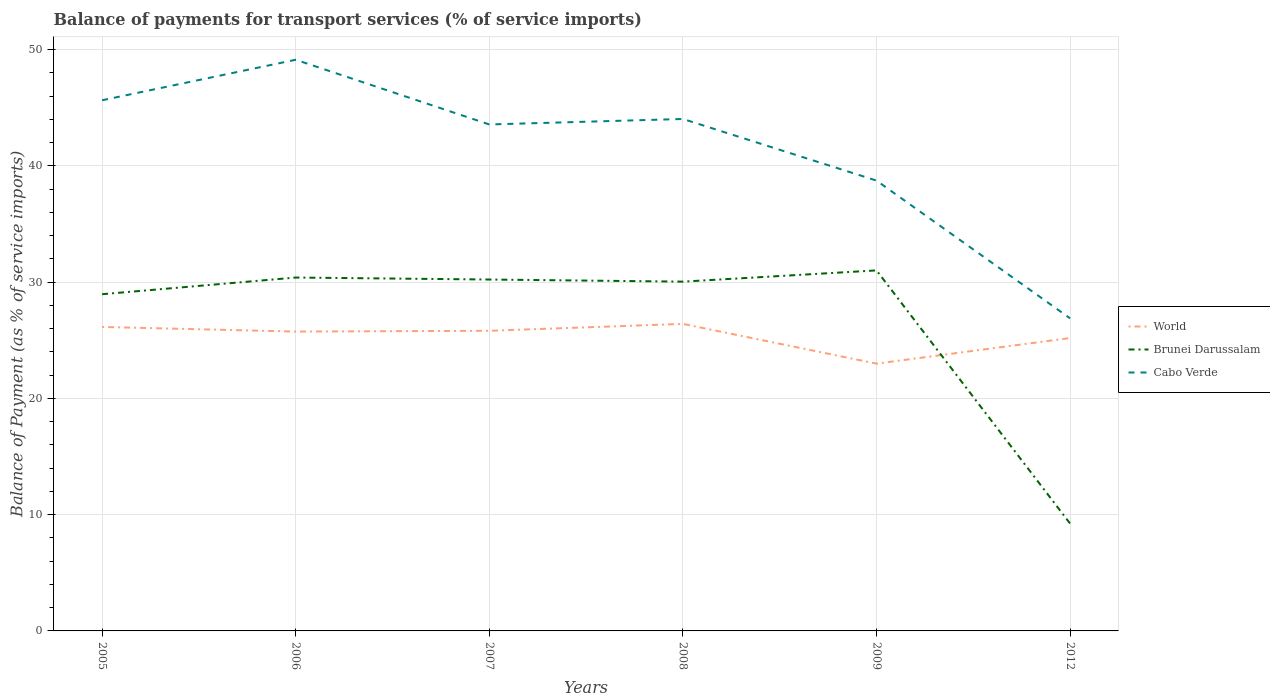How many different coloured lines are there?
Offer a very short reply. 3. Does the line corresponding to Brunei Darussalam intersect with the line corresponding to World?
Your response must be concise. Yes. Is the number of lines equal to the number of legend labels?
Keep it short and to the point. Yes. Across all years, what is the maximum balance of payments for transport services in Cabo Verde?
Provide a succinct answer. 26.88. What is the total balance of payments for transport services in Brunei Darussalam in the graph?
Make the answer very short. -1.43. What is the difference between the highest and the second highest balance of payments for transport services in Cabo Verde?
Give a very brief answer. 22.24. What is the difference between the highest and the lowest balance of payments for transport services in Brunei Darussalam?
Offer a terse response. 5. Is the balance of payments for transport services in Brunei Darussalam strictly greater than the balance of payments for transport services in World over the years?
Give a very brief answer. No. How many lines are there?
Offer a very short reply. 3. How many years are there in the graph?
Your answer should be very brief. 6. Are the values on the major ticks of Y-axis written in scientific E-notation?
Ensure brevity in your answer.  No. Does the graph contain grids?
Provide a succinct answer. Yes. How are the legend labels stacked?
Offer a terse response. Vertical. What is the title of the graph?
Ensure brevity in your answer.  Balance of payments for transport services (% of service imports). Does "Colombia" appear as one of the legend labels in the graph?
Make the answer very short. No. What is the label or title of the Y-axis?
Your response must be concise. Balance of Payment (as % of service imports). What is the Balance of Payment (as % of service imports) in World in 2005?
Provide a succinct answer. 26.14. What is the Balance of Payment (as % of service imports) of Brunei Darussalam in 2005?
Offer a very short reply. 28.96. What is the Balance of Payment (as % of service imports) in Cabo Verde in 2005?
Offer a terse response. 45.64. What is the Balance of Payment (as % of service imports) in World in 2006?
Keep it short and to the point. 25.74. What is the Balance of Payment (as % of service imports) in Brunei Darussalam in 2006?
Your answer should be very brief. 30.39. What is the Balance of Payment (as % of service imports) in Cabo Verde in 2006?
Make the answer very short. 49.12. What is the Balance of Payment (as % of service imports) in World in 2007?
Your response must be concise. 25.81. What is the Balance of Payment (as % of service imports) of Brunei Darussalam in 2007?
Your response must be concise. 30.22. What is the Balance of Payment (as % of service imports) in Cabo Verde in 2007?
Give a very brief answer. 43.56. What is the Balance of Payment (as % of service imports) of World in 2008?
Offer a very short reply. 26.4. What is the Balance of Payment (as % of service imports) in Brunei Darussalam in 2008?
Your response must be concise. 30.04. What is the Balance of Payment (as % of service imports) in Cabo Verde in 2008?
Keep it short and to the point. 44.03. What is the Balance of Payment (as % of service imports) of World in 2009?
Keep it short and to the point. 22.99. What is the Balance of Payment (as % of service imports) of Brunei Darussalam in 2009?
Provide a short and direct response. 31. What is the Balance of Payment (as % of service imports) of Cabo Verde in 2009?
Offer a terse response. 38.73. What is the Balance of Payment (as % of service imports) of World in 2012?
Offer a very short reply. 25.19. What is the Balance of Payment (as % of service imports) in Brunei Darussalam in 2012?
Make the answer very short. 9.23. What is the Balance of Payment (as % of service imports) in Cabo Verde in 2012?
Your answer should be compact. 26.88. Across all years, what is the maximum Balance of Payment (as % of service imports) in World?
Ensure brevity in your answer.  26.4. Across all years, what is the maximum Balance of Payment (as % of service imports) in Brunei Darussalam?
Your answer should be very brief. 31. Across all years, what is the maximum Balance of Payment (as % of service imports) in Cabo Verde?
Keep it short and to the point. 49.12. Across all years, what is the minimum Balance of Payment (as % of service imports) of World?
Keep it short and to the point. 22.99. Across all years, what is the minimum Balance of Payment (as % of service imports) in Brunei Darussalam?
Your answer should be very brief. 9.23. Across all years, what is the minimum Balance of Payment (as % of service imports) of Cabo Verde?
Keep it short and to the point. 26.88. What is the total Balance of Payment (as % of service imports) of World in the graph?
Provide a short and direct response. 152.27. What is the total Balance of Payment (as % of service imports) in Brunei Darussalam in the graph?
Your response must be concise. 159.84. What is the total Balance of Payment (as % of service imports) in Cabo Verde in the graph?
Your response must be concise. 247.94. What is the difference between the Balance of Payment (as % of service imports) in World in 2005 and that in 2006?
Make the answer very short. 0.4. What is the difference between the Balance of Payment (as % of service imports) of Brunei Darussalam in 2005 and that in 2006?
Give a very brief answer. -1.43. What is the difference between the Balance of Payment (as % of service imports) in Cabo Verde in 2005 and that in 2006?
Offer a very short reply. -3.48. What is the difference between the Balance of Payment (as % of service imports) of World in 2005 and that in 2007?
Make the answer very short. 0.33. What is the difference between the Balance of Payment (as % of service imports) of Brunei Darussalam in 2005 and that in 2007?
Give a very brief answer. -1.26. What is the difference between the Balance of Payment (as % of service imports) in Cabo Verde in 2005 and that in 2007?
Keep it short and to the point. 2.08. What is the difference between the Balance of Payment (as % of service imports) of World in 2005 and that in 2008?
Give a very brief answer. -0.26. What is the difference between the Balance of Payment (as % of service imports) of Brunei Darussalam in 2005 and that in 2008?
Offer a terse response. -1.08. What is the difference between the Balance of Payment (as % of service imports) in Cabo Verde in 2005 and that in 2008?
Your response must be concise. 1.61. What is the difference between the Balance of Payment (as % of service imports) in World in 2005 and that in 2009?
Keep it short and to the point. 3.15. What is the difference between the Balance of Payment (as % of service imports) of Brunei Darussalam in 2005 and that in 2009?
Provide a succinct answer. -2.05. What is the difference between the Balance of Payment (as % of service imports) in Cabo Verde in 2005 and that in 2009?
Give a very brief answer. 6.91. What is the difference between the Balance of Payment (as % of service imports) in World in 2005 and that in 2012?
Your answer should be compact. 0.95. What is the difference between the Balance of Payment (as % of service imports) in Brunei Darussalam in 2005 and that in 2012?
Give a very brief answer. 19.73. What is the difference between the Balance of Payment (as % of service imports) of Cabo Verde in 2005 and that in 2012?
Your answer should be very brief. 18.76. What is the difference between the Balance of Payment (as % of service imports) of World in 2006 and that in 2007?
Your answer should be very brief. -0.07. What is the difference between the Balance of Payment (as % of service imports) of Brunei Darussalam in 2006 and that in 2007?
Ensure brevity in your answer.  0.17. What is the difference between the Balance of Payment (as % of service imports) in Cabo Verde in 2006 and that in 2007?
Offer a very short reply. 5.56. What is the difference between the Balance of Payment (as % of service imports) of World in 2006 and that in 2008?
Give a very brief answer. -0.66. What is the difference between the Balance of Payment (as % of service imports) in Brunei Darussalam in 2006 and that in 2008?
Your answer should be very brief. 0.35. What is the difference between the Balance of Payment (as % of service imports) in Cabo Verde in 2006 and that in 2008?
Your answer should be very brief. 5.09. What is the difference between the Balance of Payment (as % of service imports) of World in 2006 and that in 2009?
Your answer should be compact. 2.76. What is the difference between the Balance of Payment (as % of service imports) of Brunei Darussalam in 2006 and that in 2009?
Provide a succinct answer. -0.61. What is the difference between the Balance of Payment (as % of service imports) of Cabo Verde in 2006 and that in 2009?
Offer a very short reply. 10.39. What is the difference between the Balance of Payment (as % of service imports) of World in 2006 and that in 2012?
Offer a terse response. 0.56. What is the difference between the Balance of Payment (as % of service imports) in Brunei Darussalam in 2006 and that in 2012?
Ensure brevity in your answer.  21.16. What is the difference between the Balance of Payment (as % of service imports) of Cabo Verde in 2006 and that in 2012?
Ensure brevity in your answer.  22.24. What is the difference between the Balance of Payment (as % of service imports) in World in 2007 and that in 2008?
Offer a terse response. -0.59. What is the difference between the Balance of Payment (as % of service imports) in Brunei Darussalam in 2007 and that in 2008?
Make the answer very short. 0.18. What is the difference between the Balance of Payment (as % of service imports) in Cabo Verde in 2007 and that in 2008?
Ensure brevity in your answer.  -0.47. What is the difference between the Balance of Payment (as % of service imports) of World in 2007 and that in 2009?
Your answer should be compact. 2.83. What is the difference between the Balance of Payment (as % of service imports) in Brunei Darussalam in 2007 and that in 2009?
Your response must be concise. -0.79. What is the difference between the Balance of Payment (as % of service imports) in Cabo Verde in 2007 and that in 2009?
Give a very brief answer. 4.83. What is the difference between the Balance of Payment (as % of service imports) of World in 2007 and that in 2012?
Offer a terse response. 0.62. What is the difference between the Balance of Payment (as % of service imports) of Brunei Darussalam in 2007 and that in 2012?
Offer a very short reply. 20.99. What is the difference between the Balance of Payment (as % of service imports) of Cabo Verde in 2007 and that in 2012?
Offer a terse response. 16.68. What is the difference between the Balance of Payment (as % of service imports) in World in 2008 and that in 2009?
Make the answer very short. 3.42. What is the difference between the Balance of Payment (as % of service imports) in Brunei Darussalam in 2008 and that in 2009?
Make the answer very short. -0.97. What is the difference between the Balance of Payment (as % of service imports) in Cabo Verde in 2008 and that in 2009?
Your response must be concise. 5.3. What is the difference between the Balance of Payment (as % of service imports) in World in 2008 and that in 2012?
Ensure brevity in your answer.  1.22. What is the difference between the Balance of Payment (as % of service imports) of Brunei Darussalam in 2008 and that in 2012?
Offer a terse response. 20.81. What is the difference between the Balance of Payment (as % of service imports) of Cabo Verde in 2008 and that in 2012?
Make the answer very short. 17.15. What is the difference between the Balance of Payment (as % of service imports) in World in 2009 and that in 2012?
Your answer should be compact. -2.2. What is the difference between the Balance of Payment (as % of service imports) of Brunei Darussalam in 2009 and that in 2012?
Provide a short and direct response. 21.77. What is the difference between the Balance of Payment (as % of service imports) in Cabo Verde in 2009 and that in 2012?
Your answer should be compact. 11.85. What is the difference between the Balance of Payment (as % of service imports) in World in 2005 and the Balance of Payment (as % of service imports) in Brunei Darussalam in 2006?
Make the answer very short. -4.25. What is the difference between the Balance of Payment (as % of service imports) in World in 2005 and the Balance of Payment (as % of service imports) in Cabo Verde in 2006?
Offer a terse response. -22.98. What is the difference between the Balance of Payment (as % of service imports) in Brunei Darussalam in 2005 and the Balance of Payment (as % of service imports) in Cabo Verde in 2006?
Your answer should be very brief. -20.16. What is the difference between the Balance of Payment (as % of service imports) in World in 2005 and the Balance of Payment (as % of service imports) in Brunei Darussalam in 2007?
Give a very brief answer. -4.08. What is the difference between the Balance of Payment (as % of service imports) of World in 2005 and the Balance of Payment (as % of service imports) of Cabo Verde in 2007?
Offer a terse response. -17.41. What is the difference between the Balance of Payment (as % of service imports) of Brunei Darussalam in 2005 and the Balance of Payment (as % of service imports) of Cabo Verde in 2007?
Ensure brevity in your answer.  -14.6. What is the difference between the Balance of Payment (as % of service imports) of World in 2005 and the Balance of Payment (as % of service imports) of Brunei Darussalam in 2008?
Your response must be concise. -3.9. What is the difference between the Balance of Payment (as % of service imports) in World in 2005 and the Balance of Payment (as % of service imports) in Cabo Verde in 2008?
Offer a very short reply. -17.89. What is the difference between the Balance of Payment (as % of service imports) in Brunei Darussalam in 2005 and the Balance of Payment (as % of service imports) in Cabo Verde in 2008?
Make the answer very short. -15.07. What is the difference between the Balance of Payment (as % of service imports) of World in 2005 and the Balance of Payment (as % of service imports) of Brunei Darussalam in 2009?
Make the answer very short. -4.86. What is the difference between the Balance of Payment (as % of service imports) in World in 2005 and the Balance of Payment (as % of service imports) in Cabo Verde in 2009?
Keep it short and to the point. -12.59. What is the difference between the Balance of Payment (as % of service imports) in Brunei Darussalam in 2005 and the Balance of Payment (as % of service imports) in Cabo Verde in 2009?
Make the answer very short. -9.77. What is the difference between the Balance of Payment (as % of service imports) of World in 2005 and the Balance of Payment (as % of service imports) of Brunei Darussalam in 2012?
Offer a very short reply. 16.91. What is the difference between the Balance of Payment (as % of service imports) in World in 2005 and the Balance of Payment (as % of service imports) in Cabo Verde in 2012?
Provide a succinct answer. -0.74. What is the difference between the Balance of Payment (as % of service imports) of Brunei Darussalam in 2005 and the Balance of Payment (as % of service imports) of Cabo Verde in 2012?
Offer a terse response. 2.08. What is the difference between the Balance of Payment (as % of service imports) in World in 2006 and the Balance of Payment (as % of service imports) in Brunei Darussalam in 2007?
Offer a terse response. -4.48. What is the difference between the Balance of Payment (as % of service imports) of World in 2006 and the Balance of Payment (as % of service imports) of Cabo Verde in 2007?
Your answer should be very brief. -17.81. What is the difference between the Balance of Payment (as % of service imports) in Brunei Darussalam in 2006 and the Balance of Payment (as % of service imports) in Cabo Verde in 2007?
Make the answer very short. -13.16. What is the difference between the Balance of Payment (as % of service imports) of World in 2006 and the Balance of Payment (as % of service imports) of Brunei Darussalam in 2008?
Keep it short and to the point. -4.29. What is the difference between the Balance of Payment (as % of service imports) of World in 2006 and the Balance of Payment (as % of service imports) of Cabo Verde in 2008?
Offer a terse response. -18.28. What is the difference between the Balance of Payment (as % of service imports) in Brunei Darussalam in 2006 and the Balance of Payment (as % of service imports) in Cabo Verde in 2008?
Your answer should be very brief. -13.64. What is the difference between the Balance of Payment (as % of service imports) of World in 2006 and the Balance of Payment (as % of service imports) of Brunei Darussalam in 2009?
Keep it short and to the point. -5.26. What is the difference between the Balance of Payment (as % of service imports) of World in 2006 and the Balance of Payment (as % of service imports) of Cabo Verde in 2009?
Make the answer very short. -12.98. What is the difference between the Balance of Payment (as % of service imports) of Brunei Darussalam in 2006 and the Balance of Payment (as % of service imports) of Cabo Verde in 2009?
Keep it short and to the point. -8.34. What is the difference between the Balance of Payment (as % of service imports) of World in 2006 and the Balance of Payment (as % of service imports) of Brunei Darussalam in 2012?
Make the answer very short. 16.51. What is the difference between the Balance of Payment (as % of service imports) in World in 2006 and the Balance of Payment (as % of service imports) in Cabo Verde in 2012?
Your response must be concise. -1.14. What is the difference between the Balance of Payment (as % of service imports) in Brunei Darussalam in 2006 and the Balance of Payment (as % of service imports) in Cabo Verde in 2012?
Make the answer very short. 3.51. What is the difference between the Balance of Payment (as % of service imports) of World in 2007 and the Balance of Payment (as % of service imports) of Brunei Darussalam in 2008?
Provide a short and direct response. -4.23. What is the difference between the Balance of Payment (as % of service imports) of World in 2007 and the Balance of Payment (as % of service imports) of Cabo Verde in 2008?
Ensure brevity in your answer.  -18.21. What is the difference between the Balance of Payment (as % of service imports) in Brunei Darussalam in 2007 and the Balance of Payment (as % of service imports) in Cabo Verde in 2008?
Keep it short and to the point. -13.81. What is the difference between the Balance of Payment (as % of service imports) in World in 2007 and the Balance of Payment (as % of service imports) in Brunei Darussalam in 2009?
Offer a terse response. -5.19. What is the difference between the Balance of Payment (as % of service imports) in World in 2007 and the Balance of Payment (as % of service imports) in Cabo Verde in 2009?
Offer a terse response. -12.92. What is the difference between the Balance of Payment (as % of service imports) in Brunei Darussalam in 2007 and the Balance of Payment (as % of service imports) in Cabo Verde in 2009?
Your answer should be very brief. -8.51. What is the difference between the Balance of Payment (as % of service imports) in World in 2007 and the Balance of Payment (as % of service imports) in Brunei Darussalam in 2012?
Your answer should be very brief. 16.58. What is the difference between the Balance of Payment (as % of service imports) in World in 2007 and the Balance of Payment (as % of service imports) in Cabo Verde in 2012?
Your response must be concise. -1.07. What is the difference between the Balance of Payment (as % of service imports) of Brunei Darussalam in 2007 and the Balance of Payment (as % of service imports) of Cabo Verde in 2012?
Give a very brief answer. 3.34. What is the difference between the Balance of Payment (as % of service imports) in World in 2008 and the Balance of Payment (as % of service imports) in Brunei Darussalam in 2009?
Your response must be concise. -4.6. What is the difference between the Balance of Payment (as % of service imports) of World in 2008 and the Balance of Payment (as % of service imports) of Cabo Verde in 2009?
Offer a very short reply. -12.32. What is the difference between the Balance of Payment (as % of service imports) of Brunei Darussalam in 2008 and the Balance of Payment (as % of service imports) of Cabo Verde in 2009?
Your response must be concise. -8.69. What is the difference between the Balance of Payment (as % of service imports) in World in 2008 and the Balance of Payment (as % of service imports) in Brunei Darussalam in 2012?
Keep it short and to the point. 17.17. What is the difference between the Balance of Payment (as % of service imports) of World in 2008 and the Balance of Payment (as % of service imports) of Cabo Verde in 2012?
Your answer should be very brief. -0.48. What is the difference between the Balance of Payment (as % of service imports) of Brunei Darussalam in 2008 and the Balance of Payment (as % of service imports) of Cabo Verde in 2012?
Your response must be concise. 3.16. What is the difference between the Balance of Payment (as % of service imports) of World in 2009 and the Balance of Payment (as % of service imports) of Brunei Darussalam in 2012?
Keep it short and to the point. 13.76. What is the difference between the Balance of Payment (as % of service imports) in World in 2009 and the Balance of Payment (as % of service imports) in Cabo Verde in 2012?
Provide a short and direct response. -3.89. What is the difference between the Balance of Payment (as % of service imports) in Brunei Darussalam in 2009 and the Balance of Payment (as % of service imports) in Cabo Verde in 2012?
Provide a succinct answer. 4.12. What is the average Balance of Payment (as % of service imports) in World per year?
Offer a very short reply. 25.38. What is the average Balance of Payment (as % of service imports) in Brunei Darussalam per year?
Keep it short and to the point. 26.64. What is the average Balance of Payment (as % of service imports) of Cabo Verde per year?
Your answer should be very brief. 41.32. In the year 2005, what is the difference between the Balance of Payment (as % of service imports) in World and Balance of Payment (as % of service imports) in Brunei Darussalam?
Your answer should be very brief. -2.82. In the year 2005, what is the difference between the Balance of Payment (as % of service imports) of World and Balance of Payment (as % of service imports) of Cabo Verde?
Provide a succinct answer. -19.5. In the year 2005, what is the difference between the Balance of Payment (as % of service imports) of Brunei Darussalam and Balance of Payment (as % of service imports) of Cabo Verde?
Make the answer very short. -16.68. In the year 2006, what is the difference between the Balance of Payment (as % of service imports) of World and Balance of Payment (as % of service imports) of Brunei Darussalam?
Offer a very short reply. -4.65. In the year 2006, what is the difference between the Balance of Payment (as % of service imports) of World and Balance of Payment (as % of service imports) of Cabo Verde?
Offer a terse response. -23.37. In the year 2006, what is the difference between the Balance of Payment (as % of service imports) of Brunei Darussalam and Balance of Payment (as % of service imports) of Cabo Verde?
Offer a terse response. -18.73. In the year 2007, what is the difference between the Balance of Payment (as % of service imports) of World and Balance of Payment (as % of service imports) of Brunei Darussalam?
Offer a very short reply. -4.41. In the year 2007, what is the difference between the Balance of Payment (as % of service imports) in World and Balance of Payment (as % of service imports) in Cabo Verde?
Keep it short and to the point. -17.74. In the year 2007, what is the difference between the Balance of Payment (as % of service imports) of Brunei Darussalam and Balance of Payment (as % of service imports) of Cabo Verde?
Provide a short and direct response. -13.34. In the year 2008, what is the difference between the Balance of Payment (as % of service imports) of World and Balance of Payment (as % of service imports) of Brunei Darussalam?
Your answer should be compact. -3.63. In the year 2008, what is the difference between the Balance of Payment (as % of service imports) of World and Balance of Payment (as % of service imports) of Cabo Verde?
Provide a succinct answer. -17.62. In the year 2008, what is the difference between the Balance of Payment (as % of service imports) of Brunei Darussalam and Balance of Payment (as % of service imports) of Cabo Verde?
Your response must be concise. -13.99. In the year 2009, what is the difference between the Balance of Payment (as % of service imports) in World and Balance of Payment (as % of service imports) in Brunei Darussalam?
Ensure brevity in your answer.  -8.02. In the year 2009, what is the difference between the Balance of Payment (as % of service imports) in World and Balance of Payment (as % of service imports) in Cabo Verde?
Offer a very short reply. -15.74. In the year 2009, what is the difference between the Balance of Payment (as % of service imports) of Brunei Darussalam and Balance of Payment (as % of service imports) of Cabo Verde?
Offer a terse response. -7.72. In the year 2012, what is the difference between the Balance of Payment (as % of service imports) of World and Balance of Payment (as % of service imports) of Brunei Darussalam?
Make the answer very short. 15.96. In the year 2012, what is the difference between the Balance of Payment (as % of service imports) of World and Balance of Payment (as % of service imports) of Cabo Verde?
Make the answer very short. -1.69. In the year 2012, what is the difference between the Balance of Payment (as % of service imports) of Brunei Darussalam and Balance of Payment (as % of service imports) of Cabo Verde?
Give a very brief answer. -17.65. What is the ratio of the Balance of Payment (as % of service imports) in World in 2005 to that in 2006?
Give a very brief answer. 1.02. What is the ratio of the Balance of Payment (as % of service imports) in Brunei Darussalam in 2005 to that in 2006?
Ensure brevity in your answer.  0.95. What is the ratio of the Balance of Payment (as % of service imports) in Cabo Verde in 2005 to that in 2006?
Your answer should be compact. 0.93. What is the ratio of the Balance of Payment (as % of service imports) of World in 2005 to that in 2007?
Offer a terse response. 1.01. What is the ratio of the Balance of Payment (as % of service imports) in Brunei Darussalam in 2005 to that in 2007?
Your response must be concise. 0.96. What is the ratio of the Balance of Payment (as % of service imports) of Cabo Verde in 2005 to that in 2007?
Make the answer very short. 1.05. What is the ratio of the Balance of Payment (as % of service imports) of Brunei Darussalam in 2005 to that in 2008?
Offer a terse response. 0.96. What is the ratio of the Balance of Payment (as % of service imports) of Cabo Verde in 2005 to that in 2008?
Offer a terse response. 1.04. What is the ratio of the Balance of Payment (as % of service imports) in World in 2005 to that in 2009?
Make the answer very short. 1.14. What is the ratio of the Balance of Payment (as % of service imports) in Brunei Darussalam in 2005 to that in 2009?
Your answer should be compact. 0.93. What is the ratio of the Balance of Payment (as % of service imports) of Cabo Verde in 2005 to that in 2009?
Give a very brief answer. 1.18. What is the ratio of the Balance of Payment (as % of service imports) of World in 2005 to that in 2012?
Ensure brevity in your answer.  1.04. What is the ratio of the Balance of Payment (as % of service imports) in Brunei Darussalam in 2005 to that in 2012?
Make the answer very short. 3.14. What is the ratio of the Balance of Payment (as % of service imports) of Cabo Verde in 2005 to that in 2012?
Your answer should be very brief. 1.7. What is the ratio of the Balance of Payment (as % of service imports) of Brunei Darussalam in 2006 to that in 2007?
Make the answer very short. 1.01. What is the ratio of the Balance of Payment (as % of service imports) in Cabo Verde in 2006 to that in 2007?
Provide a short and direct response. 1.13. What is the ratio of the Balance of Payment (as % of service imports) in Brunei Darussalam in 2006 to that in 2008?
Your response must be concise. 1.01. What is the ratio of the Balance of Payment (as % of service imports) of Cabo Verde in 2006 to that in 2008?
Offer a very short reply. 1.12. What is the ratio of the Balance of Payment (as % of service imports) in World in 2006 to that in 2009?
Give a very brief answer. 1.12. What is the ratio of the Balance of Payment (as % of service imports) of Brunei Darussalam in 2006 to that in 2009?
Provide a short and direct response. 0.98. What is the ratio of the Balance of Payment (as % of service imports) of Cabo Verde in 2006 to that in 2009?
Make the answer very short. 1.27. What is the ratio of the Balance of Payment (as % of service imports) of World in 2006 to that in 2012?
Provide a short and direct response. 1.02. What is the ratio of the Balance of Payment (as % of service imports) of Brunei Darussalam in 2006 to that in 2012?
Ensure brevity in your answer.  3.29. What is the ratio of the Balance of Payment (as % of service imports) in Cabo Verde in 2006 to that in 2012?
Provide a short and direct response. 1.83. What is the ratio of the Balance of Payment (as % of service imports) of World in 2007 to that in 2008?
Keep it short and to the point. 0.98. What is the ratio of the Balance of Payment (as % of service imports) of Cabo Verde in 2007 to that in 2008?
Offer a very short reply. 0.99. What is the ratio of the Balance of Payment (as % of service imports) in World in 2007 to that in 2009?
Offer a terse response. 1.12. What is the ratio of the Balance of Payment (as % of service imports) in Brunei Darussalam in 2007 to that in 2009?
Offer a very short reply. 0.97. What is the ratio of the Balance of Payment (as % of service imports) of Cabo Verde in 2007 to that in 2009?
Make the answer very short. 1.12. What is the ratio of the Balance of Payment (as % of service imports) in World in 2007 to that in 2012?
Your response must be concise. 1.02. What is the ratio of the Balance of Payment (as % of service imports) in Brunei Darussalam in 2007 to that in 2012?
Keep it short and to the point. 3.27. What is the ratio of the Balance of Payment (as % of service imports) in Cabo Verde in 2007 to that in 2012?
Give a very brief answer. 1.62. What is the ratio of the Balance of Payment (as % of service imports) of World in 2008 to that in 2009?
Make the answer very short. 1.15. What is the ratio of the Balance of Payment (as % of service imports) in Brunei Darussalam in 2008 to that in 2009?
Your answer should be very brief. 0.97. What is the ratio of the Balance of Payment (as % of service imports) in Cabo Verde in 2008 to that in 2009?
Make the answer very short. 1.14. What is the ratio of the Balance of Payment (as % of service imports) of World in 2008 to that in 2012?
Ensure brevity in your answer.  1.05. What is the ratio of the Balance of Payment (as % of service imports) in Brunei Darussalam in 2008 to that in 2012?
Keep it short and to the point. 3.25. What is the ratio of the Balance of Payment (as % of service imports) in Cabo Verde in 2008 to that in 2012?
Keep it short and to the point. 1.64. What is the ratio of the Balance of Payment (as % of service imports) in World in 2009 to that in 2012?
Your response must be concise. 0.91. What is the ratio of the Balance of Payment (as % of service imports) of Brunei Darussalam in 2009 to that in 2012?
Offer a very short reply. 3.36. What is the ratio of the Balance of Payment (as % of service imports) in Cabo Verde in 2009 to that in 2012?
Offer a terse response. 1.44. What is the difference between the highest and the second highest Balance of Payment (as % of service imports) of World?
Provide a short and direct response. 0.26. What is the difference between the highest and the second highest Balance of Payment (as % of service imports) of Brunei Darussalam?
Keep it short and to the point. 0.61. What is the difference between the highest and the second highest Balance of Payment (as % of service imports) in Cabo Verde?
Offer a terse response. 3.48. What is the difference between the highest and the lowest Balance of Payment (as % of service imports) of World?
Provide a succinct answer. 3.42. What is the difference between the highest and the lowest Balance of Payment (as % of service imports) of Brunei Darussalam?
Provide a short and direct response. 21.77. What is the difference between the highest and the lowest Balance of Payment (as % of service imports) of Cabo Verde?
Offer a terse response. 22.24. 